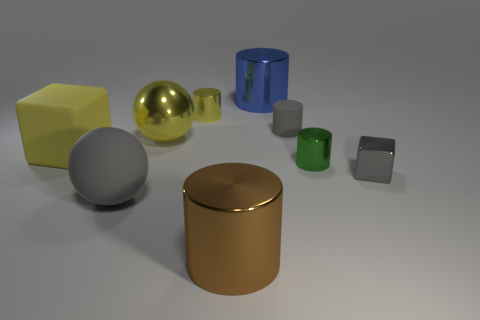Subtract all big brown cylinders. How many cylinders are left? 4 Add 1 large metal cylinders. How many objects exist? 10 Subtract all gray balls. How many balls are left? 1 Subtract all cubes. How many objects are left? 7 Subtract 1 balls. How many balls are left? 1 Subtract all green spheres. Subtract all brown cubes. How many spheres are left? 2 Subtract all blue spheres. How many blue cylinders are left? 1 Subtract all cubes. Subtract all big metallic things. How many objects are left? 4 Add 2 yellow cylinders. How many yellow cylinders are left? 3 Add 6 purple shiny things. How many purple shiny things exist? 6 